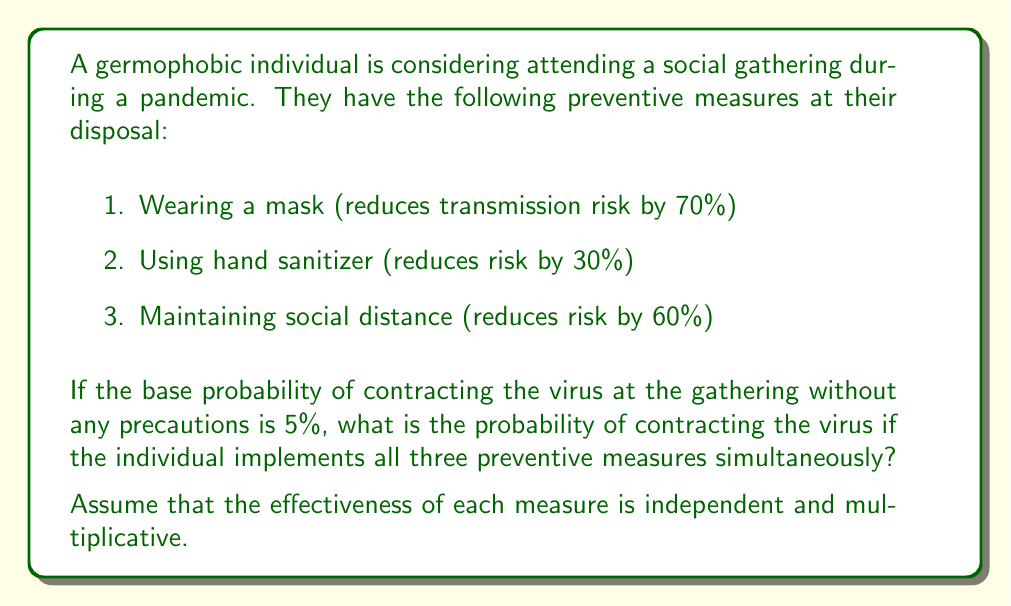Help me with this question. Let's approach this step-by-step:

1) First, we need to calculate the combined effectiveness of all three preventive measures. Since the effectiveness is multiplicative, we can calculate the remaining risk after applying each measure:

   Mask: $1 - 0.70 = 0.30$ (30% risk remains)
   Hand sanitizer: $1 - 0.30 = 0.70$ (70% risk remains)
   Social distance: $1 - 0.60 = 0.40$ (40% risk remains)

2) The total remaining risk is the product of these individual remaining risks:

   $$ \text{Total remaining risk} = 0.30 \times 0.70 \times 0.40 = 0.084 \text{ or } 8.4\% $$

3) This means that the combined preventive measures reduce the risk to 8.4% of the original risk.

4) The original risk (base probability) was 5%. To find the new probability, we multiply the base probability by the remaining risk percentage:

   $$ \text{New probability} = 0.05 \times 0.084 = 0.0042 $$

5) Convert to a percentage:

   $$ 0.0042 \times 100\% = 0.42\% $$

Therefore, the probability of contracting the virus with all preventive measures in place is 0.42%.
Answer: 0.42% 